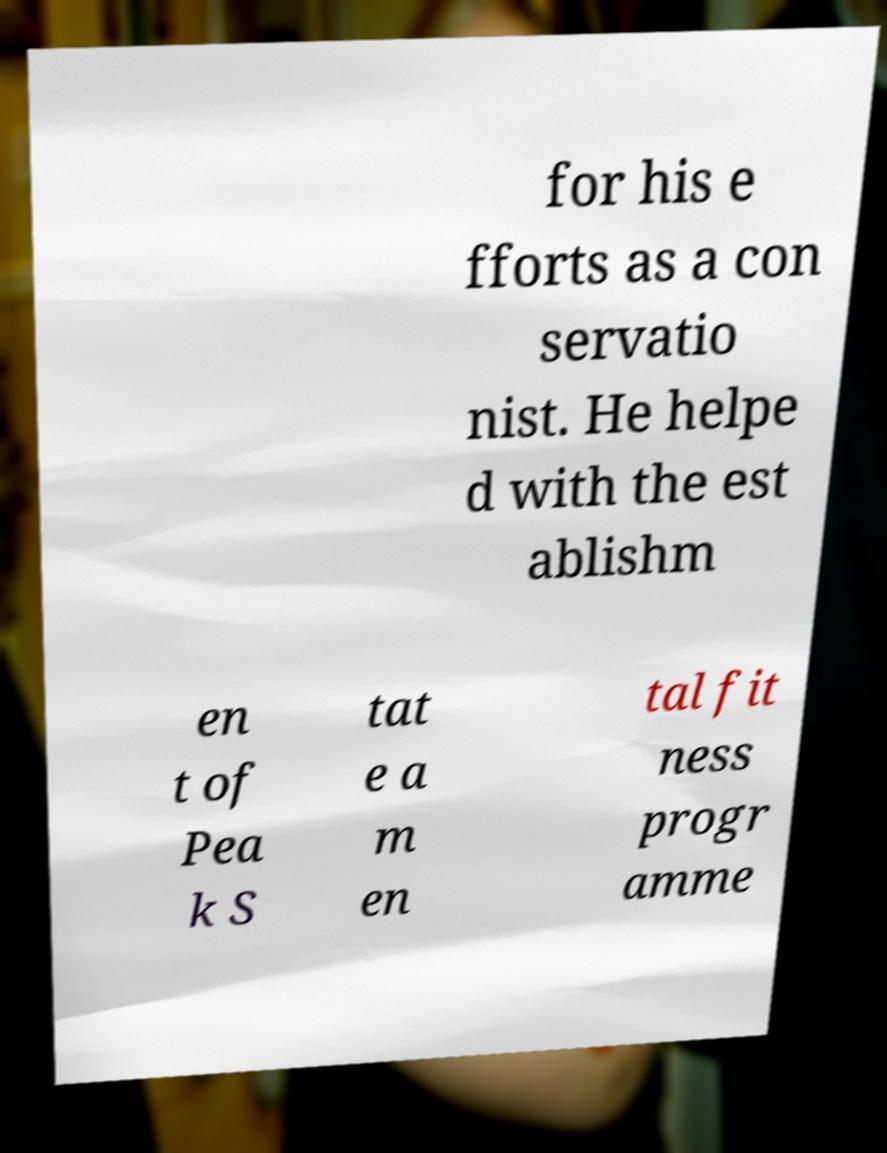For documentation purposes, I need the text within this image transcribed. Could you provide that? for his e fforts as a con servatio nist. He helpe d with the est ablishm en t of Pea k S tat e a m en tal fit ness progr amme 